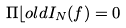<formula> <loc_0><loc_0><loc_500><loc_500>\Pi \mathcal { b } o l d { I } _ { N } ( { f } ) = { 0 }</formula> 